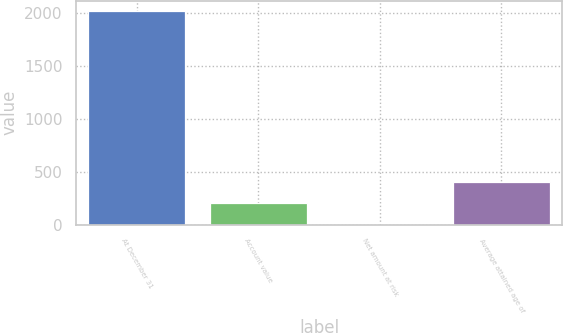Convert chart to OTSL. <chart><loc_0><loc_0><loc_500><loc_500><bar_chart><fcel>At December 31<fcel>Account value<fcel>Net amount at risk<fcel>Average attained age of<nl><fcel>2015<fcel>202.4<fcel>1<fcel>403.8<nl></chart> 